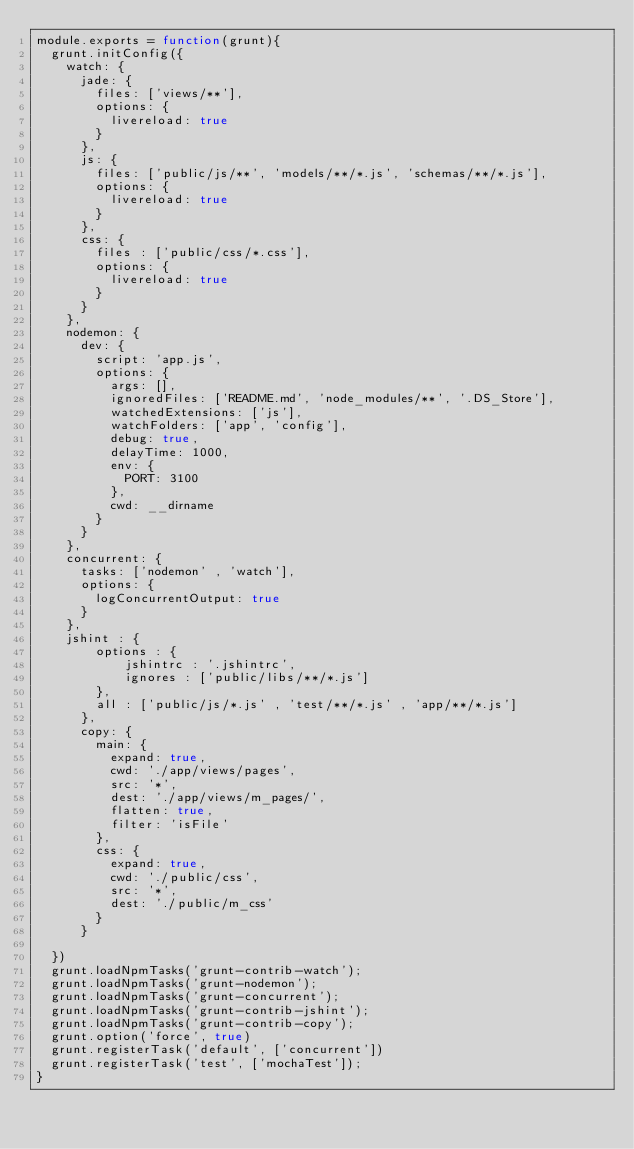<code> <loc_0><loc_0><loc_500><loc_500><_JavaScript_>module.exports = function(grunt){
	grunt.initConfig({
		watch: {
			jade: {
				files: ['views/**'],
				options: {
					livereload: true
				}
			},
			js: {
				files: ['public/js/**', 'models/**/*.js', 'schemas/**/*.js'],
				options: {
					livereload: true
				}
			},
			css: {
				files : ['public/css/*.css'],
				options: {
					livereload: true
				}
			}
		},
		nodemon: {
			dev: {
				script: 'app.js',
				options: {
					args: [],
					ignoredFiles: ['README.md', 'node_modules/**', '.DS_Store'],
					watchedExtensions: ['js'],
					watchFolders: ['app', 'config'],
					debug: true,
					delayTime: 1000,
					env: {
						PORT: 3100
					},
					cwd: __dirname
				}
			}
		},
		concurrent: {
			tasks: ['nodemon' , 'watch'],
			options: {
				logConcurrentOutput: true
			}
		},
		jshint : {
		    options : {
		        jshintrc : '.jshintrc',
		        ignores : ['public/libs/**/*.js']
		    },
		    all : ['public/js/*.js' , 'test/**/*.js' , 'app/**/*.js']
	    },
	    copy: {
	    	main: {
	    		expand: true,
	    		cwd: './app/views/pages',
    			src: '*',
    			dest: './app/views/m_pages/',
    			flatten: true,
    			filter: 'isFile'
	    	},
	    	css: {
	    		expand: true,
	    		cwd: './public/css',
	    		src: '*',
	    		dest: './public/m_css'
	    	}
	    }

	})
	grunt.loadNpmTasks('grunt-contrib-watch');
	grunt.loadNpmTasks('grunt-nodemon');
	grunt.loadNpmTasks('grunt-concurrent');
	grunt.loadNpmTasks('grunt-contrib-jshint');
	grunt.loadNpmTasks('grunt-contrib-copy');
	grunt.option('force', true)
	grunt.registerTask('default', ['concurrent'])
	grunt.registerTask('test', ['mochaTest']);
}</code> 